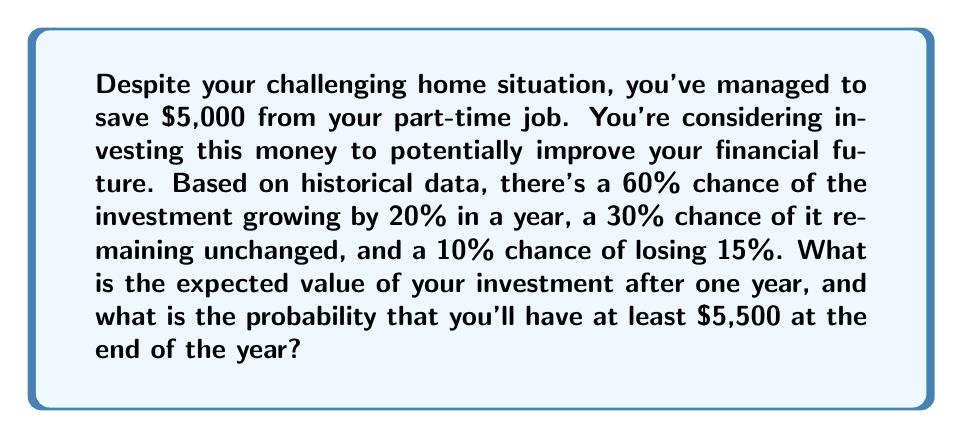Provide a solution to this math problem. Let's approach this problem step-by-step:

1) First, let's calculate the expected value of the investment after one year.

   The expected value is calculated by multiplying each possible outcome by its probability and summing these products.

   $$E = (5000 \times 1.20 \times 0.60) + (5000 \times 1.00 \times 0.30) + (5000 \times 0.85 \times 0.10)$$

   $$E = 3600 + 1500 + 425 = 5525$$

2) Now, let's calculate the probability of having at least $5,500 at the end of the year.

   This can occur in two scenarios:
   a) The investment grows by 20%
   b) The investment remains unchanged (as $5,000 is less than $5,500)

   The probability is the sum of these two scenarios:

   $$P(\text{at least } \$5,500) = 0.60 + 0.30 = 0.90$$

This means there's a 90% chance of having at least $5,500 at the end of the year.
Answer: The expected value of the investment after one year is $5,525, and the probability of having at least $5,500 at the end of the year is 0.90 or 90%. 